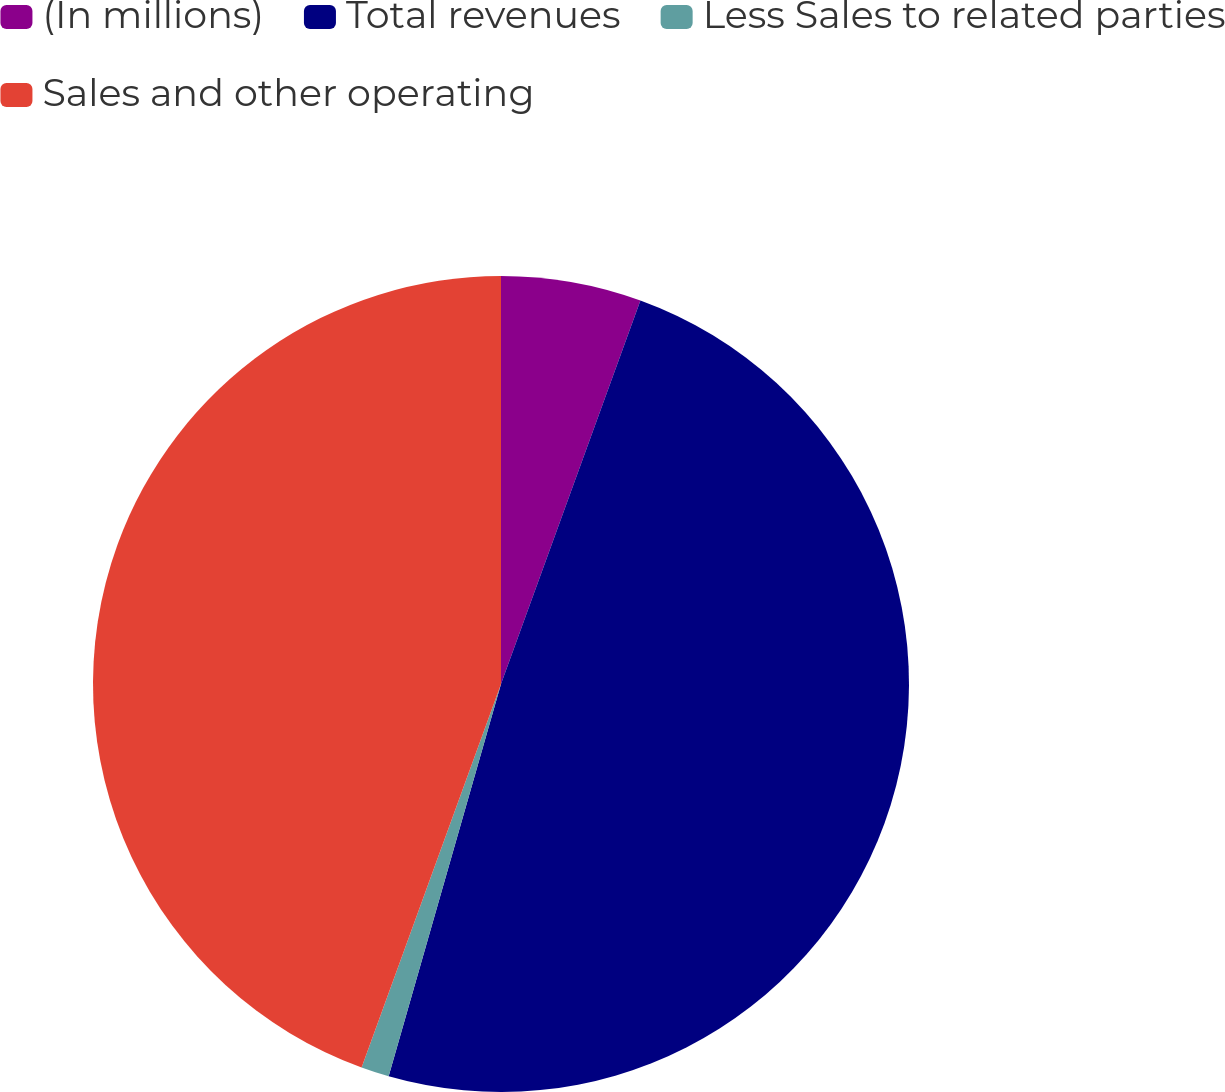<chart> <loc_0><loc_0><loc_500><loc_500><pie_chart><fcel>(In millions)<fcel>Total revenues<fcel>Less Sales to related parties<fcel>Sales and other operating<nl><fcel>5.55%<fcel>48.89%<fcel>1.11%<fcel>44.45%<nl></chart> 